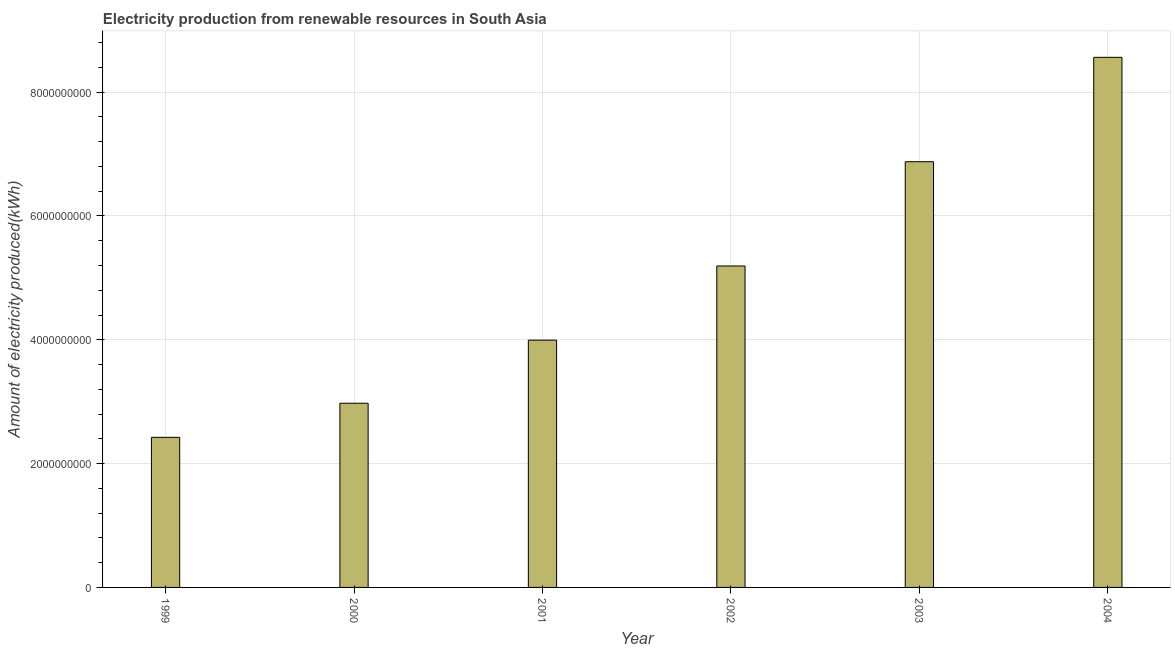What is the title of the graph?
Offer a terse response. Electricity production from renewable resources in South Asia. What is the label or title of the Y-axis?
Offer a terse response. Amount of electricity produced(kWh). What is the amount of electricity produced in 2003?
Give a very brief answer. 6.88e+09. Across all years, what is the maximum amount of electricity produced?
Give a very brief answer. 8.56e+09. Across all years, what is the minimum amount of electricity produced?
Your response must be concise. 2.42e+09. In which year was the amount of electricity produced maximum?
Offer a terse response. 2004. In which year was the amount of electricity produced minimum?
Give a very brief answer. 1999. What is the sum of the amount of electricity produced?
Your answer should be compact. 3.00e+1. What is the difference between the amount of electricity produced in 1999 and 2002?
Ensure brevity in your answer.  -2.77e+09. What is the average amount of electricity produced per year?
Keep it short and to the point. 5.00e+09. What is the median amount of electricity produced?
Your response must be concise. 4.59e+09. In how many years, is the amount of electricity produced greater than 2000000000 kWh?
Provide a short and direct response. 6. What is the ratio of the amount of electricity produced in 2001 to that in 2002?
Provide a short and direct response. 0.77. Is the difference between the amount of electricity produced in 2000 and 2003 greater than the difference between any two years?
Your response must be concise. No. What is the difference between the highest and the second highest amount of electricity produced?
Offer a terse response. 1.69e+09. What is the difference between the highest and the lowest amount of electricity produced?
Give a very brief answer. 6.14e+09. How many bars are there?
Your answer should be very brief. 6. Are all the bars in the graph horizontal?
Your response must be concise. No. Are the values on the major ticks of Y-axis written in scientific E-notation?
Offer a very short reply. No. What is the Amount of electricity produced(kWh) of 1999?
Provide a short and direct response. 2.42e+09. What is the Amount of electricity produced(kWh) in 2000?
Ensure brevity in your answer.  2.98e+09. What is the Amount of electricity produced(kWh) of 2001?
Give a very brief answer. 3.99e+09. What is the Amount of electricity produced(kWh) in 2002?
Your answer should be very brief. 5.19e+09. What is the Amount of electricity produced(kWh) in 2003?
Keep it short and to the point. 6.88e+09. What is the Amount of electricity produced(kWh) in 2004?
Offer a very short reply. 8.56e+09. What is the difference between the Amount of electricity produced(kWh) in 1999 and 2000?
Offer a terse response. -5.51e+08. What is the difference between the Amount of electricity produced(kWh) in 1999 and 2001?
Make the answer very short. -1.57e+09. What is the difference between the Amount of electricity produced(kWh) in 1999 and 2002?
Offer a very short reply. -2.77e+09. What is the difference between the Amount of electricity produced(kWh) in 1999 and 2003?
Your answer should be very brief. -4.45e+09. What is the difference between the Amount of electricity produced(kWh) in 1999 and 2004?
Give a very brief answer. -6.14e+09. What is the difference between the Amount of electricity produced(kWh) in 2000 and 2001?
Ensure brevity in your answer.  -1.02e+09. What is the difference between the Amount of electricity produced(kWh) in 2000 and 2002?
Give a very brief answer. -2.22e+09. What is the difference between the Amount of electricity produced(kWh) in 2000 and 2003?
Provide a short and direct response. -3.90e+09. What is the difference between the Amount of electricity produced(kWh) in 2000 and 2004?
Offer a terse response. -5.59e+09. What is the difference between the Amount of electricity produced(kWh) in 2001 and 2002?
Offer a terse response. -1.20e+09. What is the difference between the Amount of electricity produced(kWh) in 2001 and 2003?
Provide a short and direct response. -2.88e+09. What is the difference between the Amount of electricity produced(kWh) in 2001 and 2004?
Give a very brief answer. -4.57e+09. What is the difference between the Amount of electricity produced(kWh) in 2002 and 2003?
Your answer should be compact. -1.68e+09. What is the difference between the Amount of electricity produced(kWh) in 2002 and 2004?
Ensure brevity in your answer.  -3.37e+09. What is the difference between the Amount of electricity produced(kWh) in 2003 and 2004?
Provide a short and direct response. -1.69e+09. What is the ratio of the Amount of electricity produced(kWh) in 1999 to that in 2000?
Your answer should be very brief. 0.81. What is the ratio of the Amount of electricity produced(kWh) in 1999 to that in 2001?
Your response must be concise. 0.61. What is the ratio of the Amount of electricity produced(kWh) in 1999 to that in 2002?
Make the answer very short. 0.47. What is the ratio of the Amount of electricity produced(kWh) in 1999 to that in 2003?
Give a very brief answer. 0.35. What is the ratio of the Amount of electricity produced(kWh) in 1999 to that in 2004?
Give a very brief answer. 0.28. What is the ratio of the Amount of electricity produced(kWh) in 2000 to that in 2001?
Your response must be concise. 0.74. What is the ratio of the Amount of electricity produced(kWh) in 2000 to that in 2002?
Provide a succinct answer. 0.57. What is the ratio of the Amount of electricity produced(kWh) in 2000 to that in 2003?
Offer a very short reply. 0.43. What is the ratio of the Amount of electricity produced(kWh) in 2000 to that in 2004?
Ensure brevity in your answer.  0.35. What is the ratio of the Amount of electricity produced(kWh) in 2001 to that in 2002?
Offer a terse response. 0.77. What is the ratio of the Amount of electricity produced(kWh) in 2001 to that in 2003?
Provide a short and direct response. 0.58. What is the ratio of the Amount of electricity produced(kWh) in 2001 to that in 2004?
Ensure brevity in your answer.  0.47. What is the ratio of the Amount of electricity produced(kWh) in 2002 to that in 2003?
Your answer should be very brief. 0.76. What is the ratio of the Amount of electricity produced(kWh) in 2002 to that in 2004?
Keep it short and to the point. 0.61. What is the ratio of the Amount of electricity produced(kWh) in 2003 to that in 2004?
Ensure brevity in your answer.  0.8. 